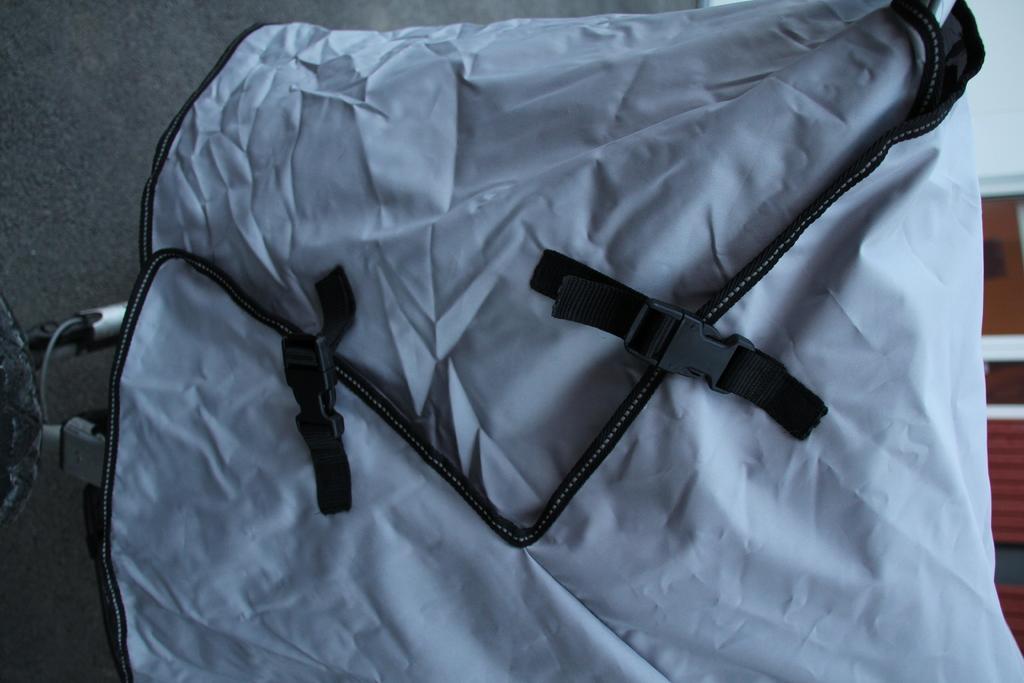In one or two sentences, can you explain what this image depicts? In the image there is a blue color bag and there are two black clips present on the bag. 